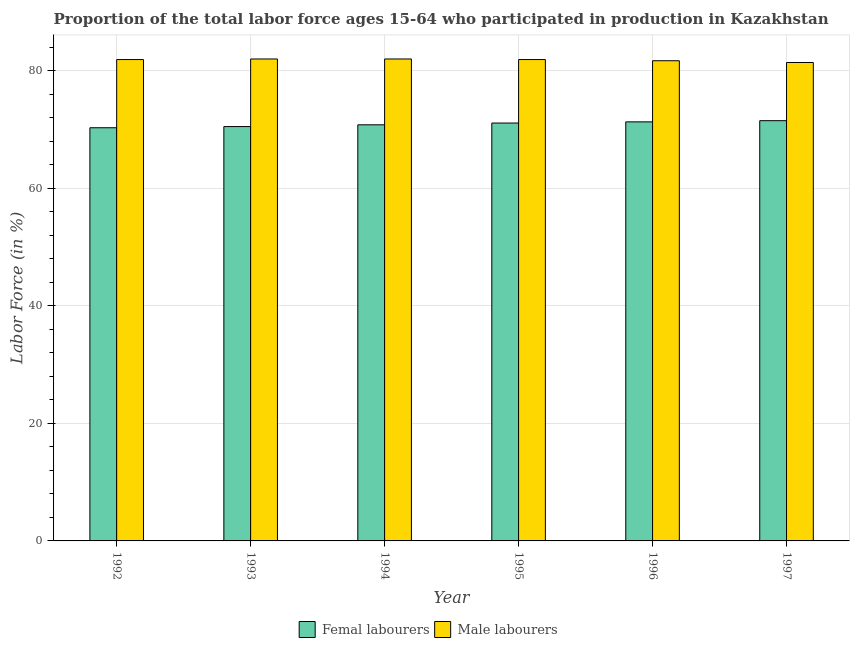How many different coloured bars are there?
Offer a terse response. 2. Are the number of bars on each tick of the X-axis equal?
Offer a very short reply. Yes. In how many cases, is the number of bars for a given year not equal to the number of legend labels?
Your response must be concise. 0. Across all years, what is the maximum percentage of female labor force?
Your answer should be compact. 71.5. Across all years, what is the minimum percentage of male labour force?
Your answer should be compact. 81.4. In which year was the percentage of male labour force maximum?
Offer a terse response. 1993. In which year was the percentage of female labor force minimum?
Your answer should be very brief. 1992. What is the total percentage of male labour force in the graph?
Your answer should be compact. 490.9. What is the difference between the percentage of female labor force in 1995 and that in 1997?
Keep it short and to the point. -0.4. What is the difference between the percentage of male labour force in 1996 and the percentage of female labor force in 1994?
Your response must be concise. -0.3. What is the average percentage of male labour force per year?
Provide a short and direct response. 81.82. In the year 1995, what is the difference between the percentage of female labor force and percentage of male labour force?
Ensure brevity in your answer.  0. What is the ratio of the percentage of male labour force in 1994 to that in 1995?
Make the answer very short. 1. Is the percentage of male labour force in 1993 less than that in 1994?
Provide a succinct answer. No. What is the difference between the highest and the second highest percentage of female labor force?
Make the answer very short. 0.2. What is the difference between the highest and the lowest percentage of male labour force?
Provide a succinct answer. 0.6. What does the 1st bar from the left in 1992 represents?
Offer a very short reply. Femal labourers. What does the 2nd bar from the right in 1996 represents?
Your answer should be compact. Femal labourers. What is the difference between two consecutive major ticks on the Y-axis?
Offer a very short reply. 20. Does the graph contain grids?
Your answer should be very brief. Yes. How many legend labels are there?
Your answer should be very brief. 2. How are the legend labels stacked?
Your answer should be compact. Horizontal. What is the title of the graph?
Offer a very short reply. Proportion of the total labor force ages 15-64 who participated in production in Kazakhstan. Does "Old" appear as one of the legend labels in the graph?
Keep it short and to the point. No. What is the Labor Force (in %) of Femal labourers in 1992?
Offer a terse response. 70.3. What is the Labor Force (in %) of Male labourers in 1992?
Your answer should be very brief. 81.9. What is the Labor Force (in %) in Femal labourers in 1993?
Provide a succinct answer. 70.5. What is the Labor Force (in %) of Male labourers in 1993?
Provide a short and direct response. 82. What is the Labor Force (in %) in Femal labourers in 1994?
Provide a succinct answer. 70.8. What is the Labor Force (in %) in Male labourers in 1994?
Keep it short and to the point. 82. What is the Labor Force (in %) of Femal labourers in 1995?
Offer a very short reply. 71.1. What is the Labor Force (in %) in Male labourers in 1995?
Offer a terse response. 81.9. What is the Labor Force (in %) of Femal labourers in 1996?
Give a very brief answer. 71.3. What is the Labor Force (in %) of Male labourers in 1996?
Provide a short and direct response. 81.7. What is the Labor Force (in %) in Femal labourers in 1997?
Provide a short and direct response. 71.5. What is the Labor Force (in %) in Male labourers in 1997?
Keep it short and to the point. 81.4. Across all years, what is the maximum Labor Force (in %) of Femal labourers?
Make the answer very short. 71.5. Across all years, what is the minimum Labor Force (in %) of Femal labourers?
Your answer should be compact. 70.3. Across all years, what is the minimum Labor Force (in %) of Male labourers?
Your response must be concise. 81.4. What is the total Labor Force (in %) in Femal labourers in the graph?
Your answer should be compact. 425.5. What is the total Labor Force (in %) of Male labourers in the graph?
Make the answer very short. 490.9. What is the difference between the Labor Force (in %) in Male labourers in 1992 and that in 1993?
Your answer should be very brief. -0.1. What is the difference between the Labor Force (in %) in Femal labourers in 1992 and that in 1994?
Offer a very short reply. -0.5. What is the difference between the Labor Force (in %) of Femal labourers in 1992 and that in 1995?
Provide a short and direct response. -0.8. What is the difference between the Labor Force (in %) in Femal labourers in 1992 and that in 1997?
Ensure brevity in your answer.  -1.2. What is the difference between the Labor Force (in %) in Male labourers in 1993 and that in 1994?
Offer a terse response. 0. What is the difference between the Labor Force (in %) of Femal labourers in 1993 and that in 1995?
Ensure brevity in your answer.  -0.6. What is the difference between the Labor Force (in %) of Male labourers in 1993 and that in 1995?
Provide a succinct answer. 0.1. What is the difference between the Labor Force (in %) in Male labourers in 1993 and that in 1997?
Keep it short and to the point. 0.6. What is the difference between the Labor Force (in %) in Femal labourers in 1994 and that in 1996?
Your response must be concise. -0.5. What is the difference between the Labor Force (in %) in Femal labourers in 1994 and that in 1997?
Ensure brevity in your answer.  -0.7. What is the difference between the Labor Force (in %) in Femal labourers in 1995 and that in 1996?
Provide a succinct answer. -0.2. What is the difference between the Labor Force (in %) of Femal labourers in 1995 and that in 1997?
Ensure brevity in your answer.  -0.4. What is the difference between the Labor Force (in %) of Femal labourers in 1996 and that in 1997?
Ensure brevity in your answer.  -0.2. What is the difference between the Labor Force (in %) of Femal labourers in 1992 and the Labor Force (in %) of Male labourers in 1993?
Your response must be concise. -11.7. What is the difference between the Labor Force (in %) of Femal labourers in 1992 and the Labor Force (in %) of Male labourers in 1996?
Your response must be concise. -11.4. What is the difference between the Labor Force (in %) in Femal labourers in 1993 and the Labor Force (in %) in Male labourers in 1994?
Make the answer very short. -11.5. What is the difference between the Labor Force (in %) in Femal labourers in 1993 and the Labor Force (in %) in Male labourers in 1995?
Keep it short and to the point. -11.4. What is the difference between the Labor Force (in %) in Femal labourers in 1994 and the Labor Force (in %) in Male labourers in 1995?
Provide a succinct answer. -11.1. What is the difference between the Labor Force (in %) of Femal labourers in 1994 and the Labor Force (in %) of Male labourers in 1996?
Give a very brief answer. -10.9. What is the difference between the Labor Force (in %) of Femal labourers in 1995 and the Labor Force (in %) of Male labourers in 1997?
Provide a short and direct response. -10.3. What is the average Labor Force (in %) of Femal labourers per year?
Provide a succinct answer. 70.92. What is the average Labor Force (in %) in Male labourers per year?
Provide a short and direct response. 81.82. In the year 1995, what is the difference between the Labor Force (in %) of Femal labourers and Labor Force (in %) of Male labourers?
Your answer should be very brief. -10.8. What is the ratio of the Labor Force (in %) in Male labourers in 1992 to that in 1994?
Ensure brevity in your answer.  1. What is the ratio of the Labor Force (in %) of Femal labourers in 1992 to that in 1995?
Ensure brevity in your answer.  0.99. What is the ratio of the Labor Force (in %) of Femal labourers in 1992 to that in 1996?
Your answer should be compact. 0.99. What is the ratio of the Labor Force (in %) of Femal labourers in 1992 to that in 1997?
Ensure brevity in your answer.  0.98. What is the ratio of the Labor Force (in %) in Male labourers in 1993 to that in 1994?
Keep it short and to the point. 1. What is the ratio of the Labor Force (in %) in Male labourers in 1993 to that in 1995?
Provide a succinct answer. 1. What is the ratio of the Labor Force (in %) of Femal labourers in 1993 to that in 1996?
Offer a very short reply. 0.99. What is the ratio of the Labor Force (in %) in Male labourers in 1993 to that in 1997?
Give a very brief answer. 1.01. What is the ratio of the Labor Force (in %) of Femal labourers in 1994 to that in 1995?
Your answer should be very brief. 1. What is the ratio of the Labor Force (in %) in Femal labourers in 1994 to that in 1996?
Provide a succinct answer. 0.99. What is the ratio of the Labor Force (in %) of Male labourers in 1994 to that in 1996?
Offer a terse response. 1. What is the ratio of the Labor Force (in %) of Femal labourers in 1994 to that in 1997?
Ensure brevity in your answer.  0.99. What is the ratio of the Labor Force (in %) in Male labourers in 1994 to that in 1997?
Your response must be concise. 1.01. What is the ratio of the Labor Force (in %) in Male labourers in 1995 to that in 1997?
Your answer should be very brief. 1.01. What is the ratio of the Labor Force (in %) of Male labourers in 1996 to that in 1997?
Offer a very short reply. 1. What is the difference between the highest and the lowest Labor Force (in %) in Femal labourers?
Your answer should be very brief. 1.2. What is the difference between the highest and the lowest Labor Force (in %) in Male labourers?
Give a very brief answer. 0.6. 